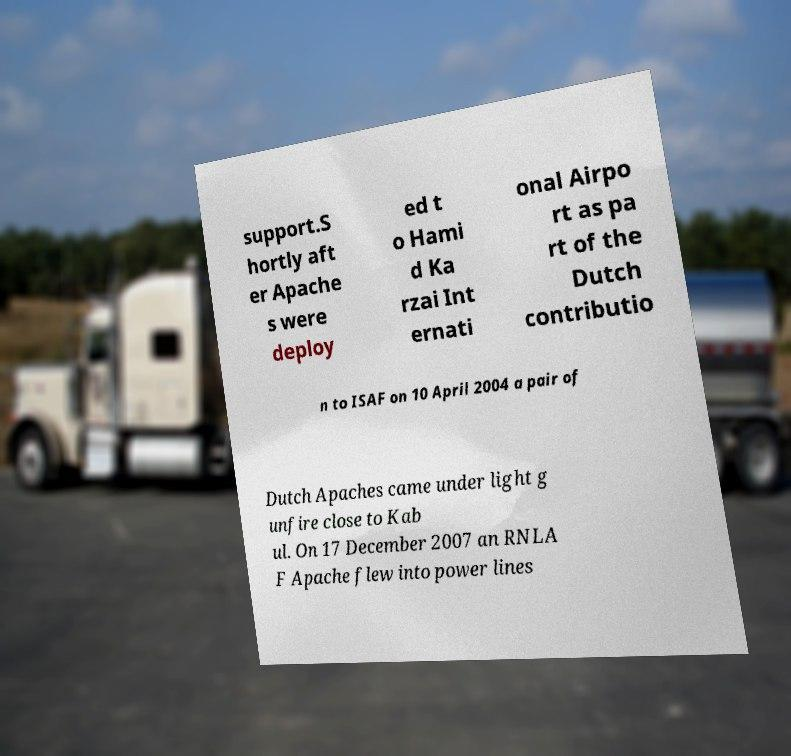Could you assist in decoding the text presented in this image and type it out clearly? support.S hortly aft er Apache s were deploy ed t o Hami d Ka rzai Int ernati onal Airpo rt as pa rt of the Dutch contributio n to ISAF on 10 April 2004 a pair of Dutch Apaches came under light g unfire close to Kab ul. On 17 December 2007 an RNLA F Apache flew into power lines 